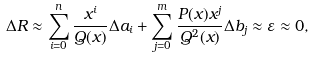<formula> <loc_0><loc_0><loc_500><loc_500>\Delta R \approx \sum ^ { n } _ { i = 0 } \frac { x ^ { i } } { Q ( x ) } \Delta a _ { i } + \sum ^ { m } _ { j = 0 } \frac { P ( x ) x ^ { j } } { Q ^ { 2 } ( x ) } \Delta b _ { j } \approx \varepsilon \approx 0 ,</formula> 